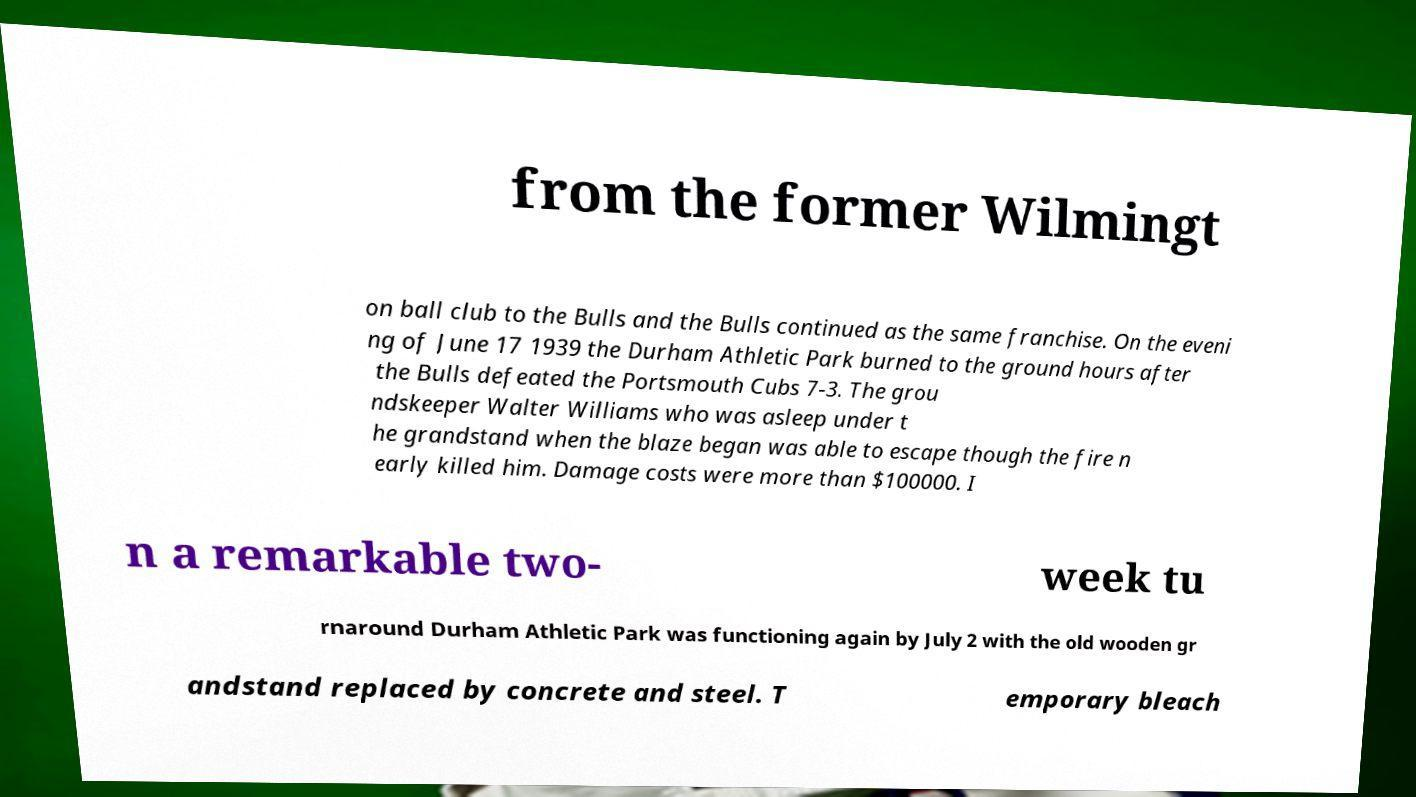Could you extract and type out the text from this image? from the former Wilmingt on ball club to the Bulls and the Bulls continued as the same franchise. On the eveni ng of June 17 1939 the Durham Athletic Park burned to the ground hours after the Bulls defeated the Portsmouth Cubs 7-3. The grou ndskeeper Walter Williams who was asleep under t he grandstand when the blaze began was able to escape though the fire n early killed him. Damage costs were more than $100000. I n a remarkable two- week tu rnaround Durham Athletic Park was functioning again by July 2 with the old wooden gr andstand replaced by concrete and steel. T emporary bleach 